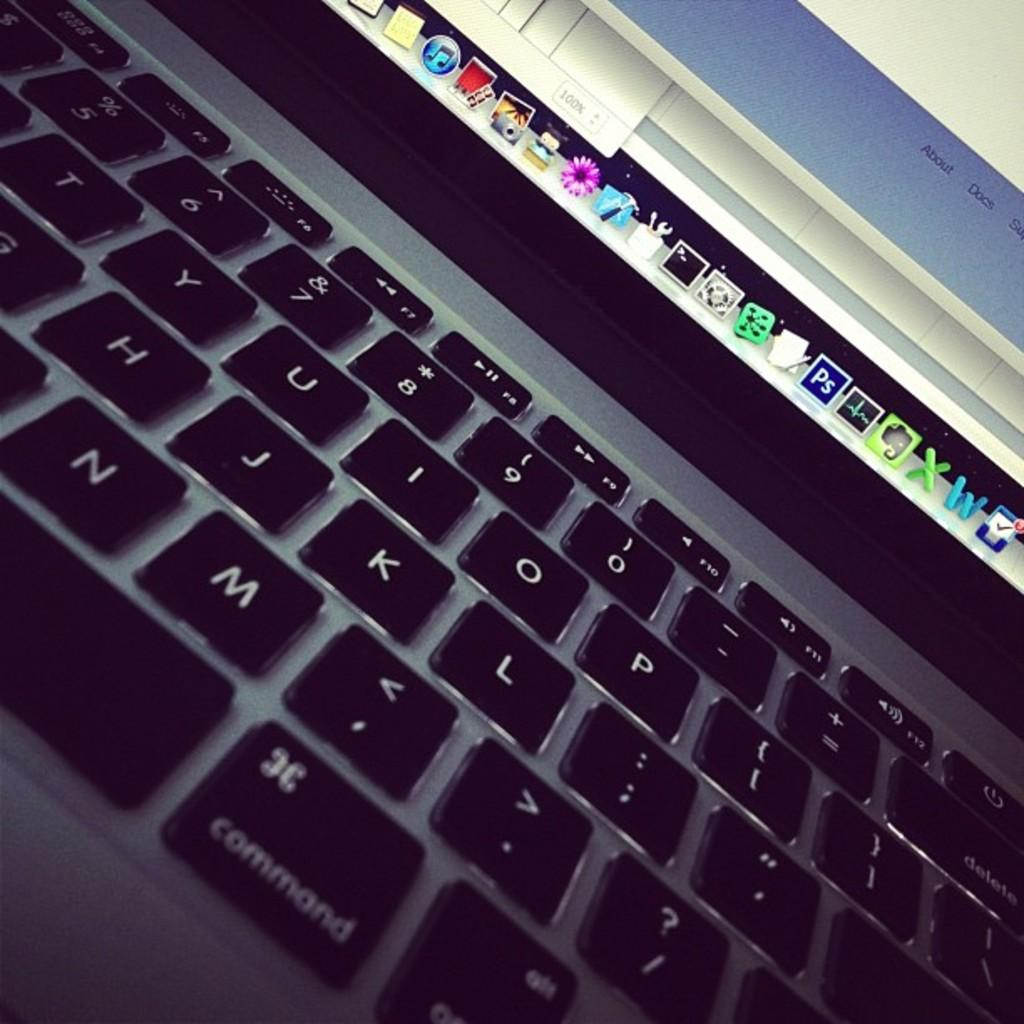<image>
Provide a brief description of the given image. A laptop is open and the command key is just below the left arrow key. 